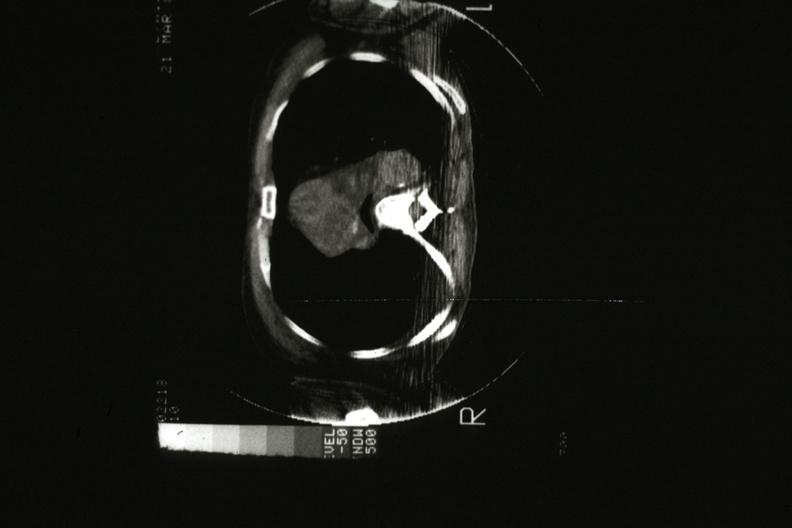what is present?
Answer the question using a single word or phrase. Malignant thymoma 